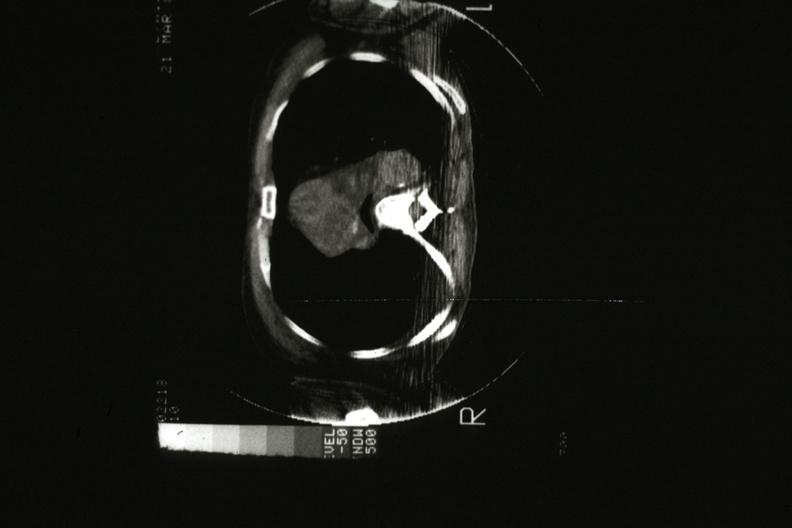what is present?
Answer the question using a single word or phrase. Malignant thymoma 